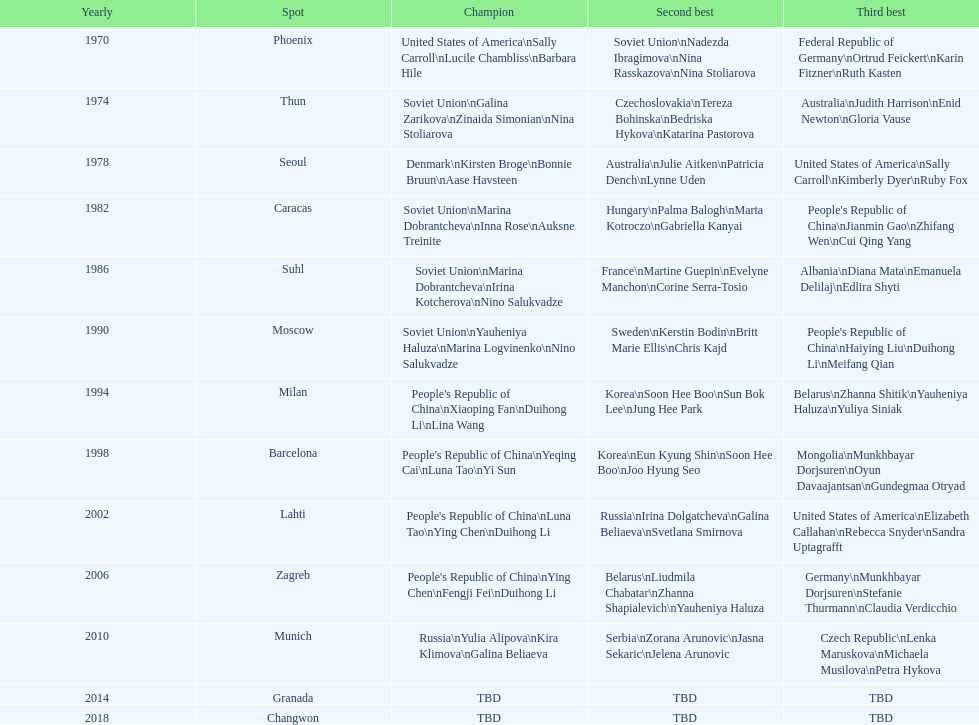Could you parse the entire table? {'header': ['Yearly', 'Spot', 'Champion', 'Second best', 'Third best'], 'rows': [['1970', 'Phoenix', 'United States of America\\nSally Carroll\\nLucile Chambliss\\nBarbara Hile', 'Soviet Union\\nNadezda Ibragimova\\nNina Rasskazova\\nNina Stoliarova', 'Federal Republic of Germany\\nOrtrud Feickert\\nKarin Fitzner\\nRuth Kasten'], ['1974', 'Thun', 'Soviet Union\\nGalina Zarikova\\nZinaida Simonian\\nNina Stoliarova', 'Czechoslovakia\\nTereza Bohinska\\nBedriska Hykova\\nKatarina Pastorova', 'Australia\\nJudith Harrison\\nEnid Newton\\nGloria Vause'], ['1978', 'Seoul', 'Denmark\\nKirsten Broge\\nBonnie Bruun\\nAase Havsteen', 'Australia\\nJulie Aitken\\nPatricia Dench\\nLynne Uden', 'United States of America\\nSally Carroll\\nKimberly Dyer\\nRuby Fox'], ['1982', 'Caracas', 'Soviet Union\\nMarina Dobrantcheva\\nInna Rose\\nAuksne Treinite', 'Hungary\\nPalma Balogh\\nMarta Kotroczo\\nGabriella Kanyai', "People's Republic of China\\nJianmin Gao\\nZhifang Wen\\nCui Qing Yang"], ['1986', 'Suhl', 'Soviet Union\\nMarina Dobrantcheva\\nIrina Kotcherova\\nNino Salukvadze', 'France\\nMartine Guepin\\nEvelyne Manchon\\nCorine Serra-Tosio', 'Albania\\nDiana Mata\\nEmanuela Delilaj\\nEdlira Shyti'], ['1990', 'Moscow', 'Soviet Union\\nYauheniya Haluza\\nMarina Logvinenko\\nNino Salukvadze', 'Sweden\\nKerstin Bodin\\nBritt Marie Ellis\\nChris Kajd', "People's Republic of China\\nHaiying Liu\\nDuihong Li\\nMeifang Qian"], ['1994', 'Milan', "People's Republic of China\\nXiaoping Fan\\nDuihong Li\\nLina Wang", 'Korea\\nSoon Hee Boo\\nSun Bok Lee\\nJung Hee Park', 'Belarus\\nZhanna Shitik\\nYauheniya Haluza\\nYuliya Siniak'], ['1998', 'Barcelona', "People's Republic of China\\nYeqing Cai\\nLuna Tao\\nYi Sun", 'Korea\\nEun Kyung Shin\\nSoon Hee Boo\\nJoo Hyung Seo', 'Mongolia\\nMunkhbayar Dorjsuren\\nOyun Davaajantsan\\nGundegmaa Otryad'], ['2002', 'Lahti', "People's Republic of China\\nLuna Tao\\nYing Chen\\nDuihong Li", 'Russia\\nIrina Dolgatcheva\\nGalina Beliaeva\\nSvetlana Smirnova', 'United States of America\\nElizabeth Callahan\\nRebecca Snyder\\nSandra Uptagrafft'], ['2006', 'Zagreb', "People's Republic of China\\nYing Chen\\nFengji Fei\\nDuihong Li", 'Belarus\\nLiudmila Chabatar\\nZhanna Shapialevich\\nYauheniya Haluza', 'Germany\\nMunkhbayar Dorjsuren\\nStefanie Thurmann\\nClaudia Verdicchio'], ['2010', 'Munich', 'Russia\\nYulia Alipova\\nKira Klimova\\nGalina Beliaeva', 'Serbia\\nZorana Arunovic\\nJasna Sekaric\\nJelena Arunovic', 'Czech Republic\\nLenka Maruskova\\nMichaela Musilova\\nPetra Hykova'], ['2014', 'Granada', 'TBD', 'TBD', 'TBD'], ['2018', 'Changwon', 'TBD', 'TBD', 'TBD']]} How many occurrences are there of the soviet union being mentioned in the gold column? 4. 